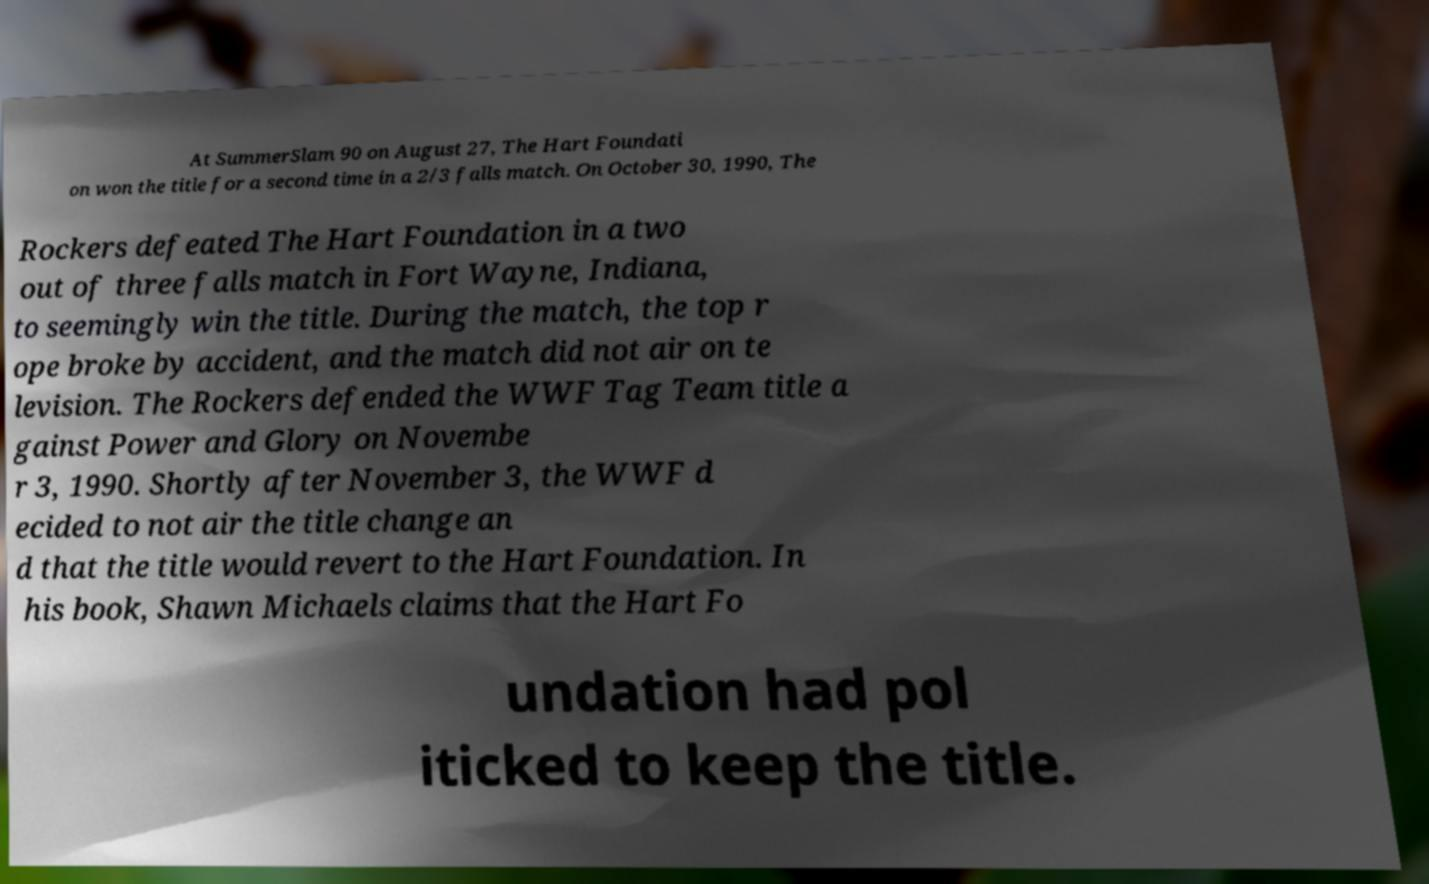What messages or text are displayed in this image? I need them in a readable, typed format. At SummerSlam 90 on August 27, The Hart Foundati on won the title for a second time in a 2/3 falls match. On October 30, 1990, The Rockers defeated The Hart Foundation in a two out of three falls match in Fort Wayne, Indiana, to seemingly win the title. During the match, the top r ope broke by accident, and the match did not air on te levision. The Rockers defended the WWF Tag Team title a gainst Power and Glory on Novembe r 3, 1990. Shortly after November 3, the WWF d ecided to not air the title change an d that the title would revert to the Hart Foundation. In his book, Shawn Michaels claims that the Hart Fo undation had pol iticked to keep the title. 